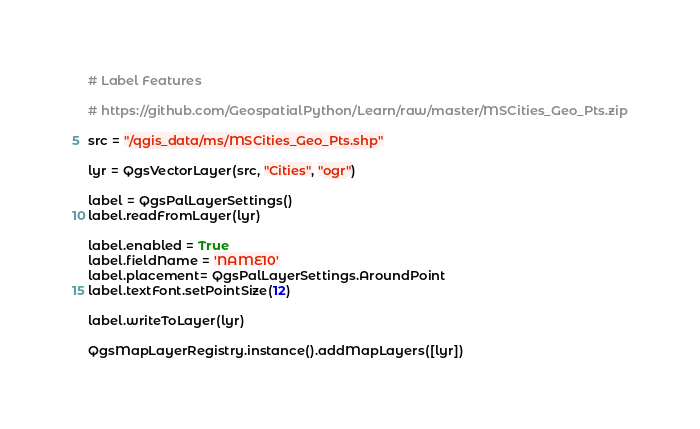<code> <loc_0><loc_0><loc_500><loc_500><_Python_># Label Features

# https://github.com/GeospatialPython/Learn/raw/master/MSCities_Geo_Pts.zip

src = "/qgis_data/ms/MSCities_Geo_Pts.shp"

lyr = QgsVectorLayer(src, "Cities", "ogr")

label = QgsPalLayerSettings() 
label.readFromLayer(lyr) 

label.enabled = True 
label.fieldName = 'NAME10' 
label.placement= QgsPalLayerSettings.AroundPoint 
label.textFont.setPointSize(12)

label.writeToLayer(lyr) 

QgsMapLayerRegistry.instance().addMapLayers([lyr])</code> 